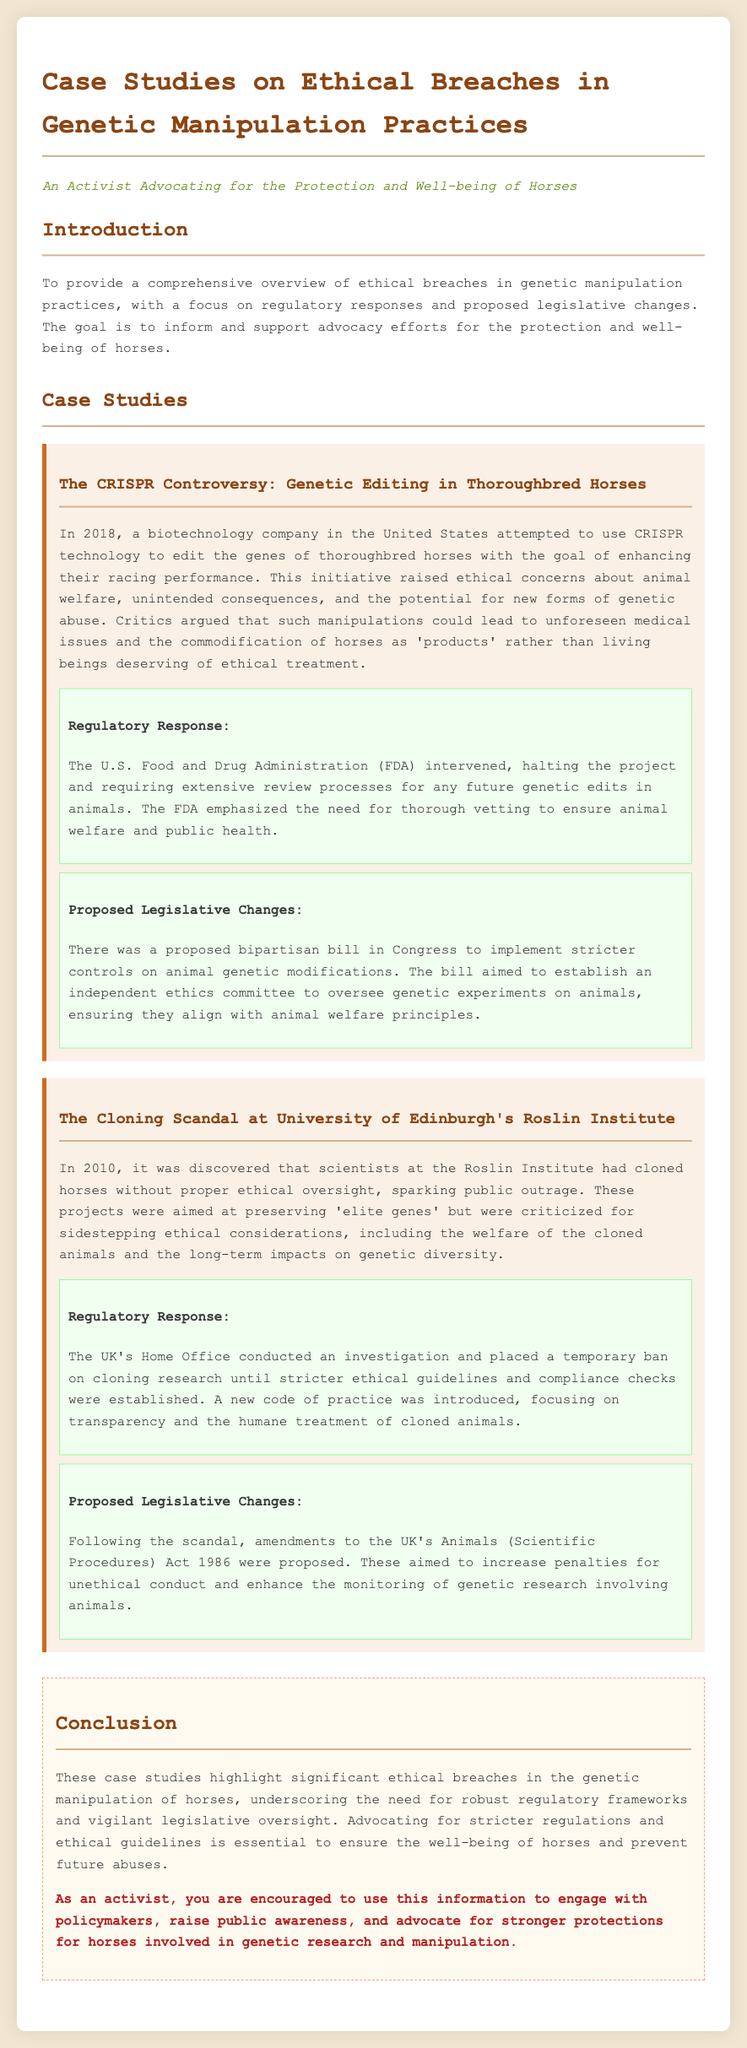What biotechnology company attempted to use CRISPR technology in 2018? The document mentions a biotechnology company in the United States that attempted to use CRISPR technology for thoroughbred horses.
Answer: biotechnology company What was the main goal of the 2018 CRISPR initiative? The initiative aimed to enhance the racing performance of thoroughbred horses.
Answer: enhance racing performance Which organization halted the CRISPR project? The U.S. Food and Drug Administration (FDA) intervened and halted the project.
Answer: FDA When was the cloning scandal at the University of Edinburgh's Roslin Institute revealed? The scandal was discovered in 2010.
Answer: 2010 What did the new code of practice introduced in the UK focus on? The new code of practice focused on transparency and the humane treatment of cloned animals.
Answer: transparency and humane treatment How many pieces of legislation were proposed after the CRISPR controversy? There was a proposed bipartisan bill in Congress related to genetic modifications.
Answer: one What was the primary reason for proposed amendments to the UK's Animals (Scientific Procedures) Act 1986? The amendments were proposed to increase penalties for unethical conduct in genetic research.
Answer: increase penalties What ethical considerations were sidestepped during the horse cloning projects? Ethical considerations sidestepped included the welfare of cloned animals and the long-term impacts on genetic diversity.
Answer: welfare and genetic diversity What is the document encouraging activists to do with the information provided? The document encourages activists to engage with policymakers and raise public awareness.
Answer: engage with policymakers and raise public awareness 